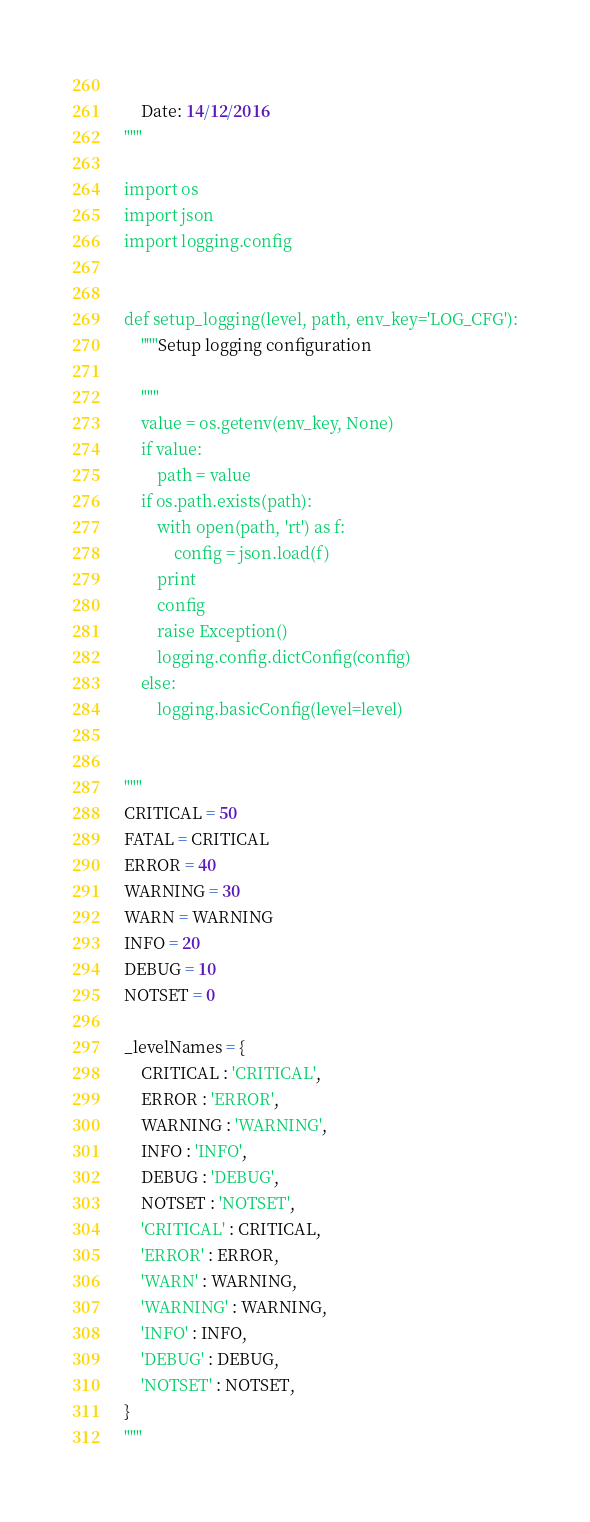<code> <loc_0><loc_0><loc_500><loc_500><_Python_>    
    Date: 14/12/2016
"""

import os
import json
import logging.config


def setup_logging(level, path, env_key='LOG_CFG'):
    """Setup logging configuration

    """
    value = os.getenv(env_key, None)
    if value:
        path = value
    if os.path.exists(path):
        with open(path, 'rt') as f:
            config = json.load(f)
        print
        config
        raise Exception()
        logging.config.dictConfig(config)
    else:
        logging.basicConfig(level=level)


"""     
CRITICAL = 50
FATAL = CRITICAL
ERROR = 40
WARNING = 30
WARN = WARNING
INFO = 20
DEBUG = 10
NOTSET = 0
      
_levelNames = {
    CRITICAL : 'CRITICAL',
    ERROR : 'ERROR',
    WARNING : 'WARNING',
    INFO : 'INFO',
    DEBUG : 'DEBUG',
    NOTSET : 'NOTSET',
    'CRITICAL' : CRITICAL,
    'ERROR' : ERROR,
    'WARN' : WARNING,
    'WARNING' : WARNING,
    'INFO' : INFO,
    'DEBUG' : DEBUG,
    'NOTSET' : NOTSET,
}      
"""
</code> 